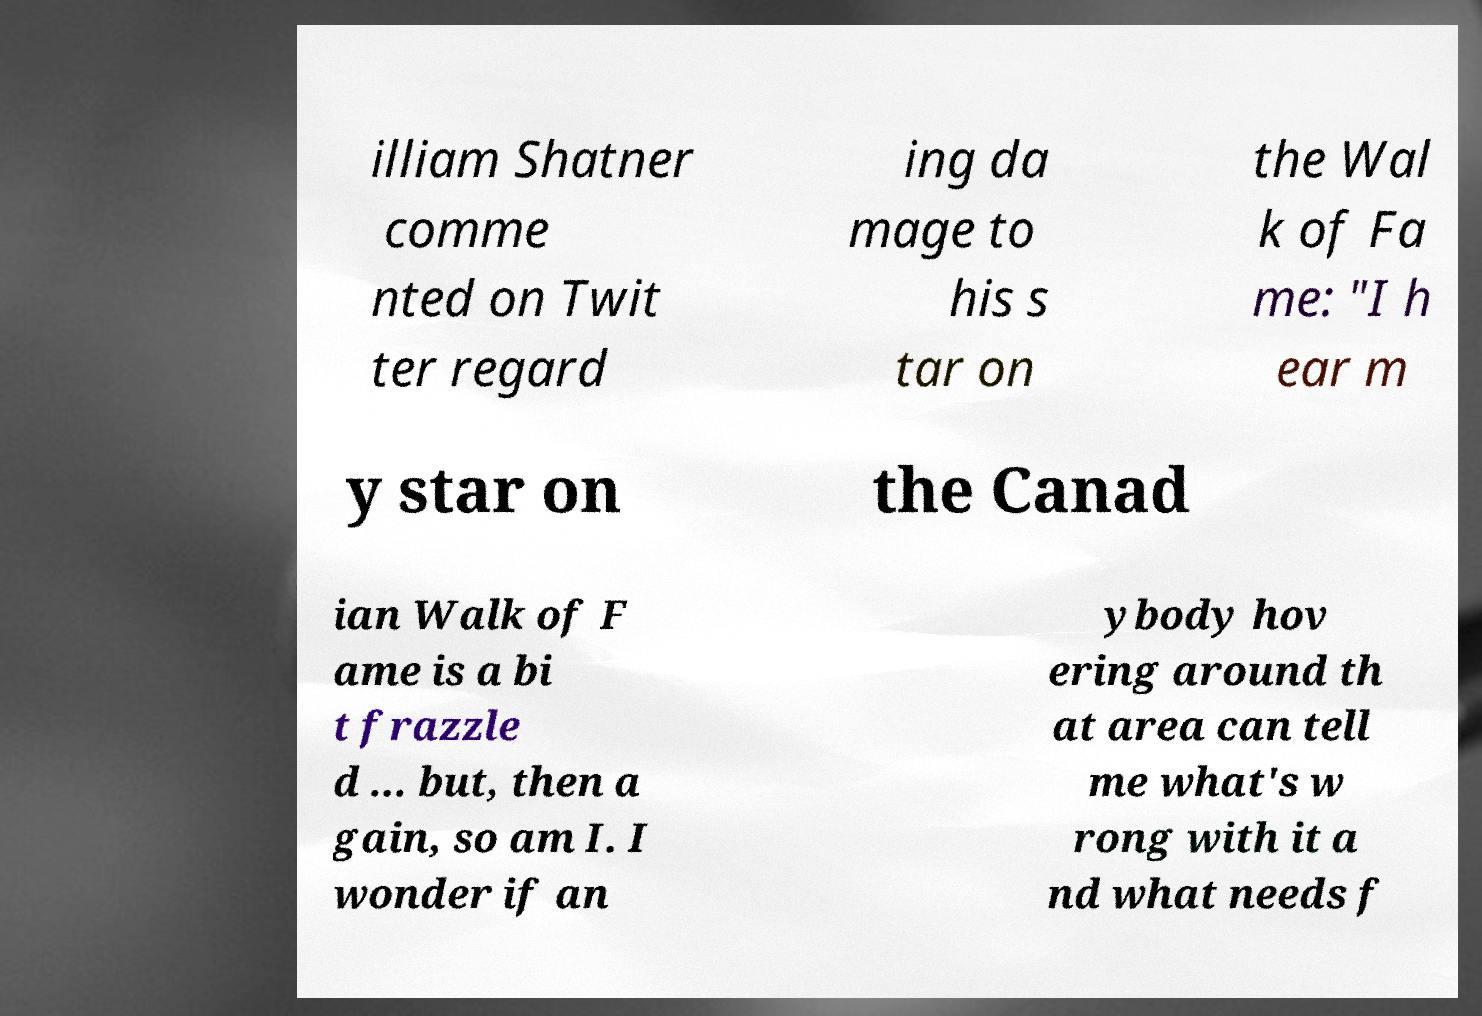Please identify and transcribe the text found in this image. illiam Shatner comme nted on Twit ter regard ing da mage to his s tar on the Wal k of Fa me: "I h ear m y star on the Canad ian Walk of F ame is a bi t frazzle d ... but, then a gain, so am I. I wonder if an ybody hov ering around th at area can tell me what's w rong with it a nd what needs f 